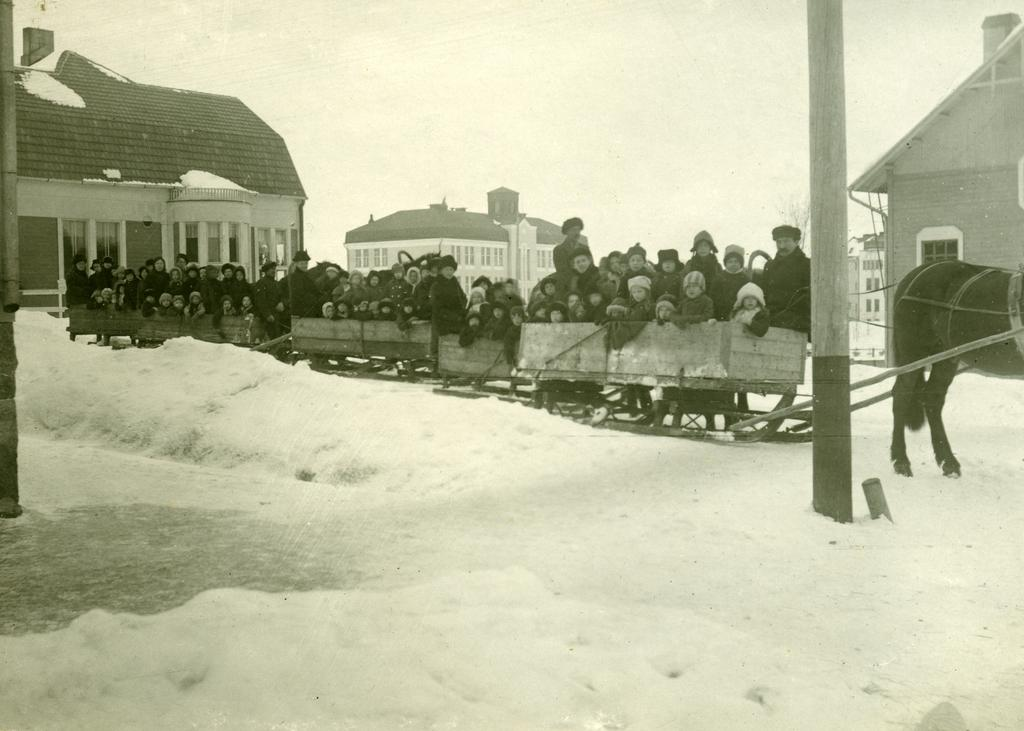What type of vehicle are the persons sitting in? The persons are sitting in the carriages of a sledge cart. What is pulling the sledge cart? The sledge cart is drawn by a horse. What can be seen in the background of the image? There is sky, buildings, poles, and snow visible in the background of the image. What type of picture is hanging on the wall in the image? There is no picture hanging on the wall in the image; it is a sledge cart with persons sitting in it and a horse pulling it. What type of cloud can be seen in the image? There is no cloud visible in the image; it is a sledge cart with persons sitting in it, a horse pulling it, and a background with sky, buildings, poles, and snow. 